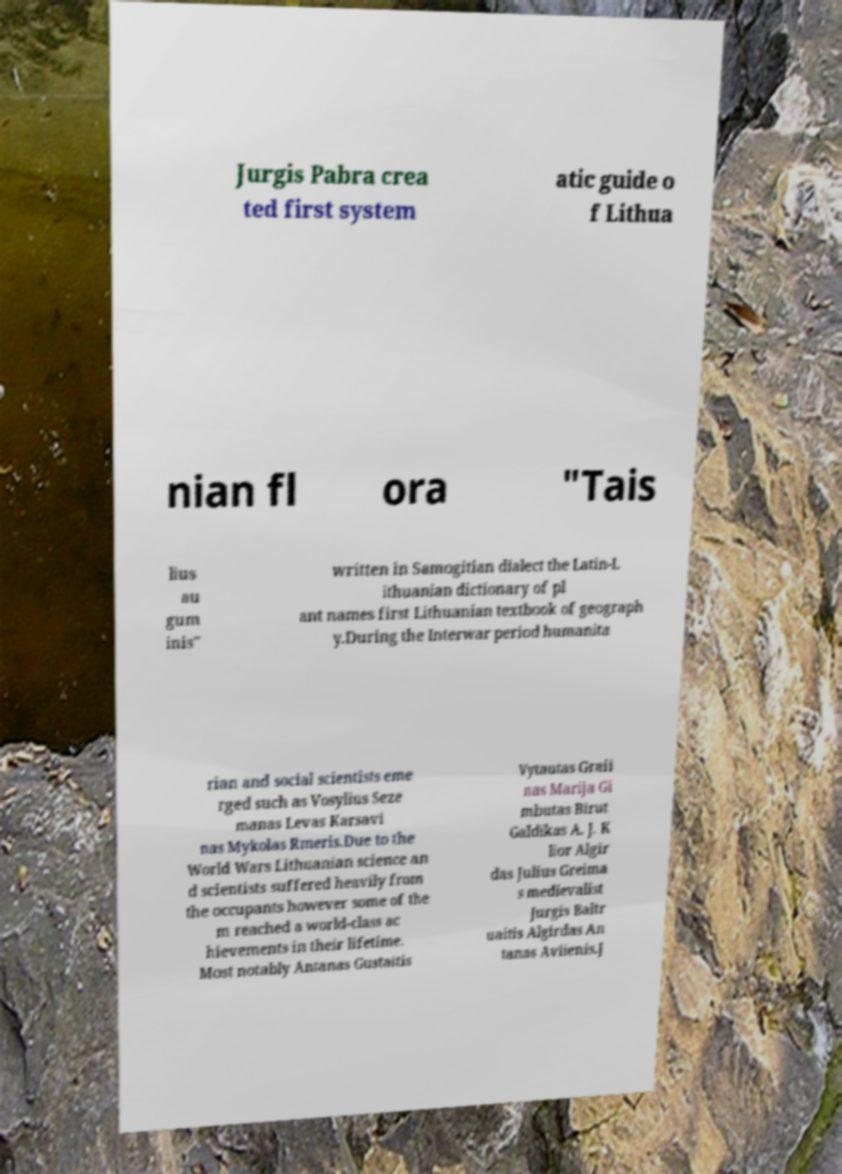Can you accurately transcribe the text from the provided image for me? Jurgis Pabra crea ted first system atic guide o f Lithua nian fl ora "Tais lius au gum inis" written in Samogitian dialect the Latin-L ithuanian dictionary of pl ant names first Lithuanian textbook of geograph y.During the Interwar period humanita rian and social scientists eme rged such as Vosylius Seze manas Levas Karsavi nas Mykolas Rmeris.Due to the World Wars Lithuanian science an d scientists suffered heavily from the occupants however some of the m reached a world-class ac hievements in their lifetime. Most notably Antanas Gustaitis Vytautas Graii nas Marija Gi mbutas Birut Galdikas A. J. K lior Algir das Julius Greima s medievalist Jurgis Baltr uaitis Algirdas An tanas Aviienis.J 